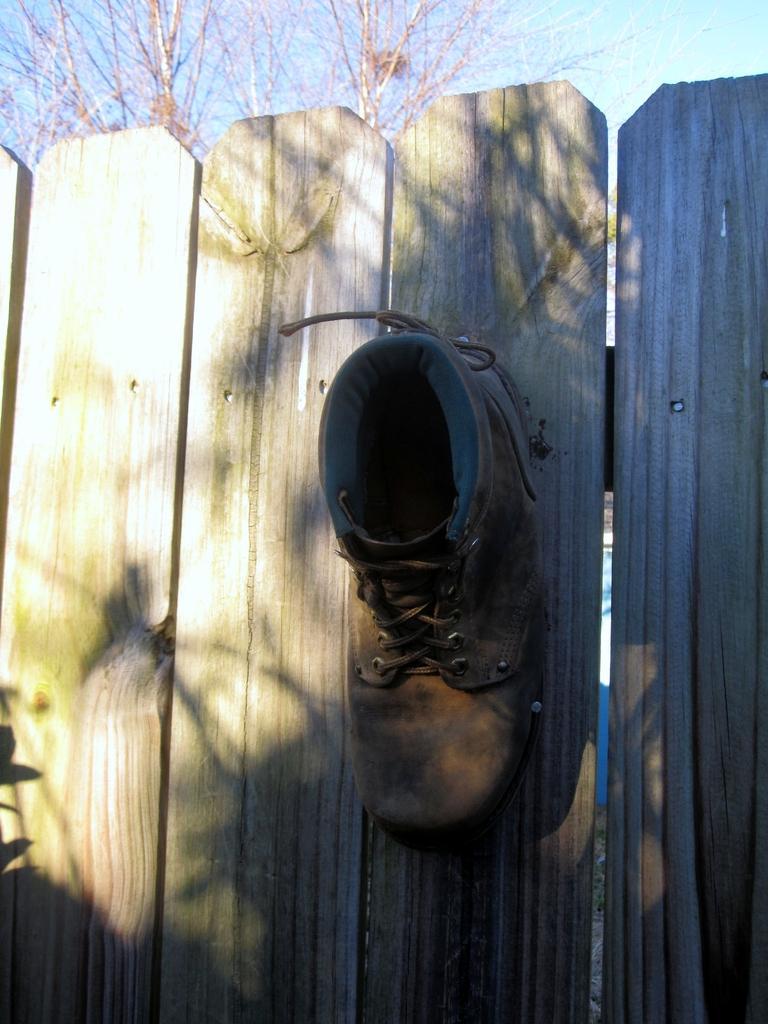How would you summarize this image in a sentence or two? In this image I can see a shoe on a wooden fence. There is a tree at the back and sky at the top. 